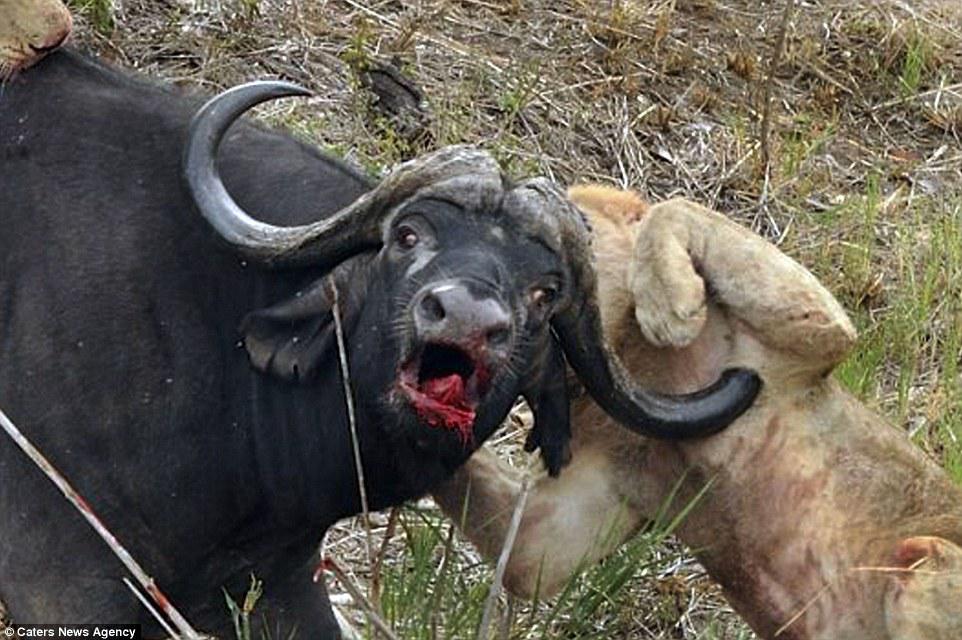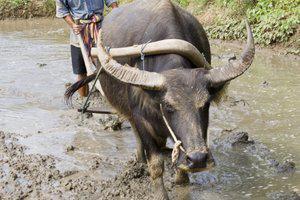The first image is the image on the left, the second image is the image on the right. Assess this claim about the two images: "No other animal is pictured except for two bulls.". Correct or not? Answer yes or no. No. 